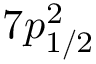Convert formula to latex. <formula><loc_0><loc_0><loc_500><loc_500>7 p _ { 1 / 2 } ^ { 2 }</formula> 